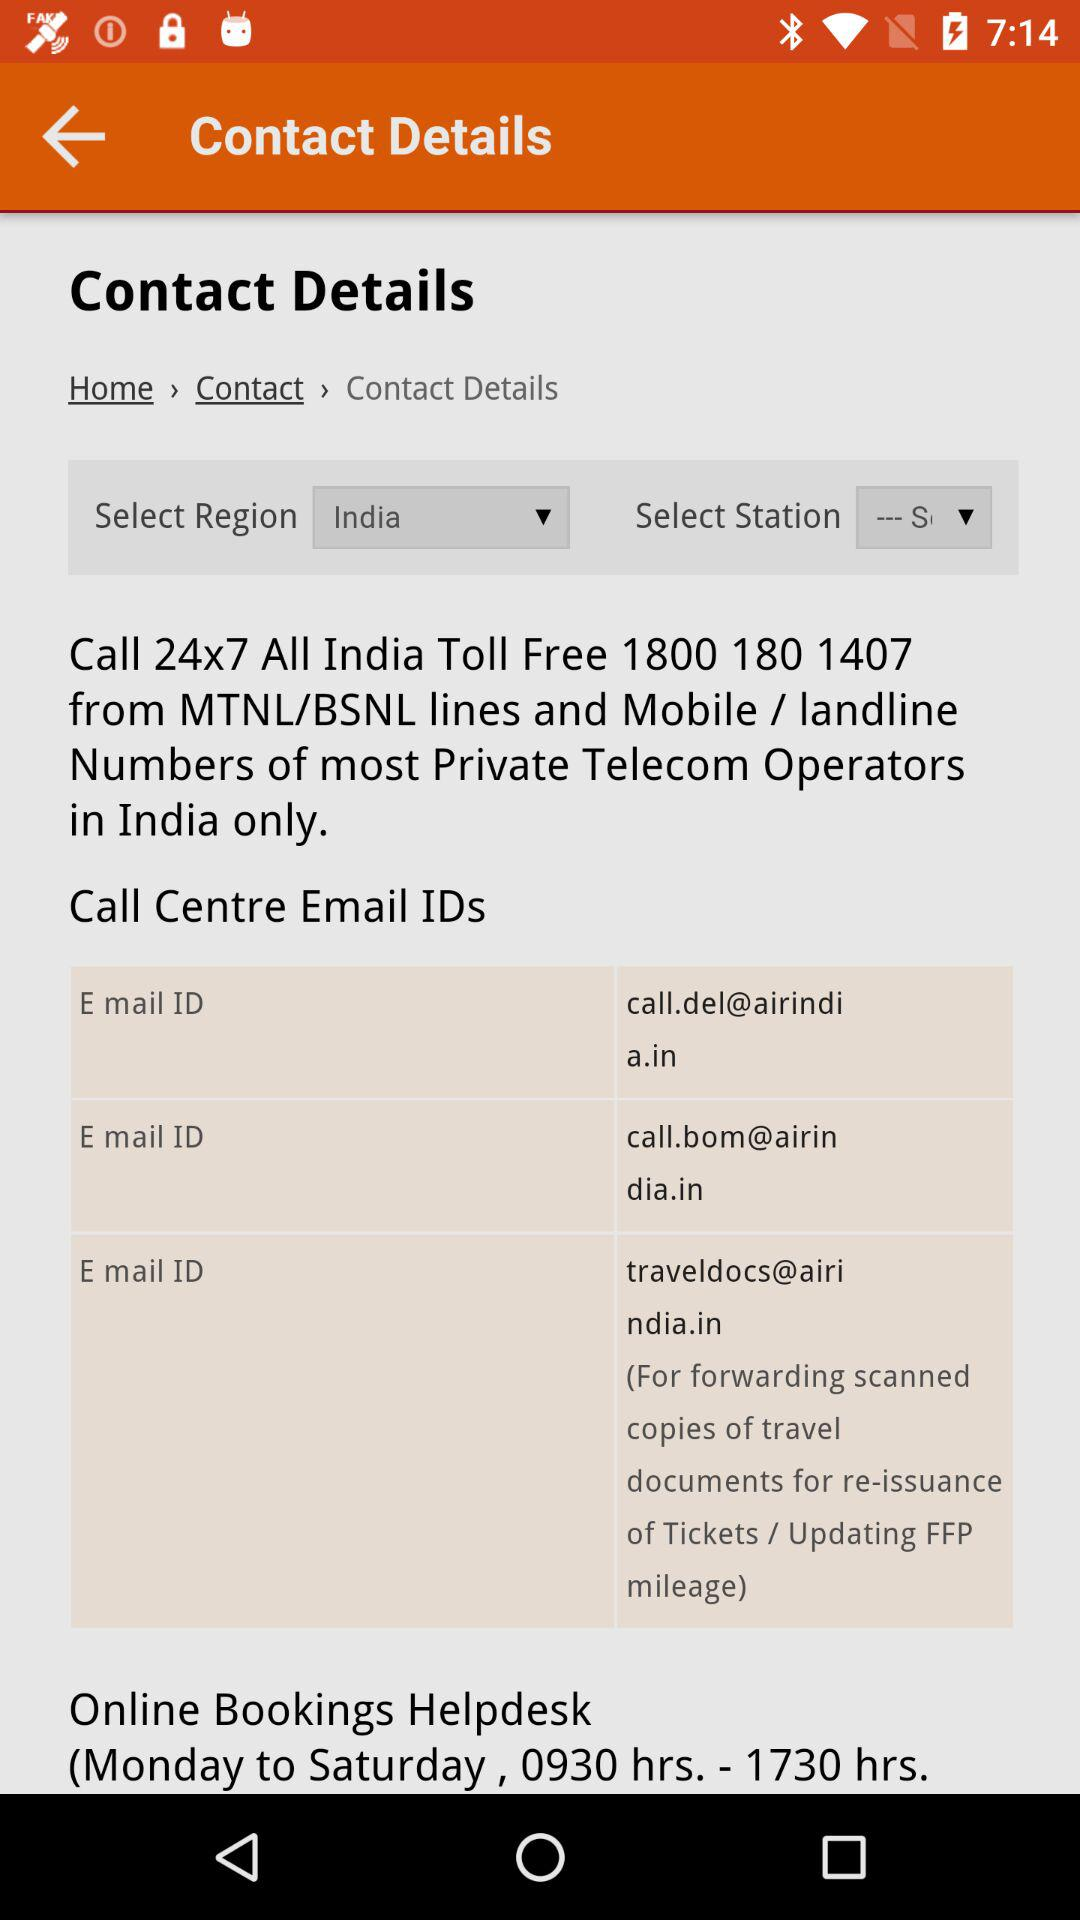What is the toll free number? The toll free number is 18001801407. 